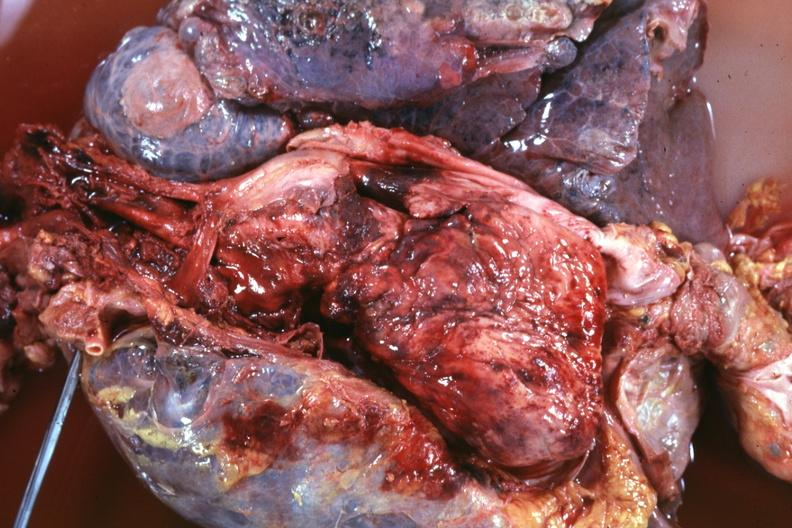what is thoracic organs dissected?
Answer the question using a single word or phrase. To show super cava and region of tumor invasion quite good 